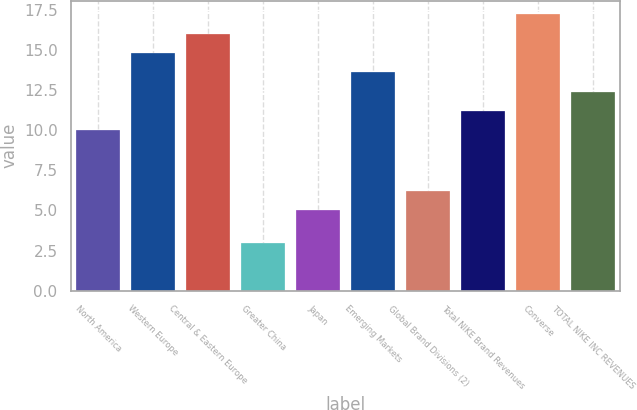Convert chart to OTSL. <chart><loc_0><loc_0><loc_500><loc_500><bar_chart><fcel>North America<fcel>Western Europe<fcel>Central & Eastern Europe<fcel>Greater China<fcel>Japan<fcel>Emerging Markets<fcel>Global Brand Divisions (2)<fcel>Total NIKE Brand Revenues<fcel>Converse<fcel>TOTAL NIKE INC REVENUES<nl><fcel>10<fcel>14.8<fcel>16<fcel>3<fcel>5<fcel>13.6<fcel>6.2<fcel>11.2<fcel>17.2<fcel>12.4<nl></chart> 